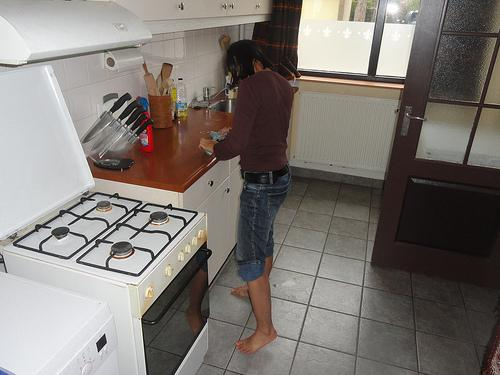Question: what does the lady have on her legs?
Choices:
A. Striped stockings.
B. Knee highs.
C. Stretch pants.
D. Jeans.
Answer with the letter. Answer: D Question: where in the photo is the oven?
Choices:
A. In the background.
B. Bottom left.
C. Behind the counter.
D. Next to the pantry.
Answer with the letter. Answer: B Question: how many knives are in the knife holder?
Choices:
A. Five.
B. Three.
C. None.
D. All of them.
Answer with the letter. Answer: A Question: who is standing next to the woman?
Choices:
A. A man.
B. Her daughter.
C. Her son.
D. No one.
Answer with the letter. Answer: D Question: where was this photo taken?
Choices:
A. On the patio.
B. Kitchen.
C. On the veranda.
D. In the garden.
Answer with the letter. Answer: B 